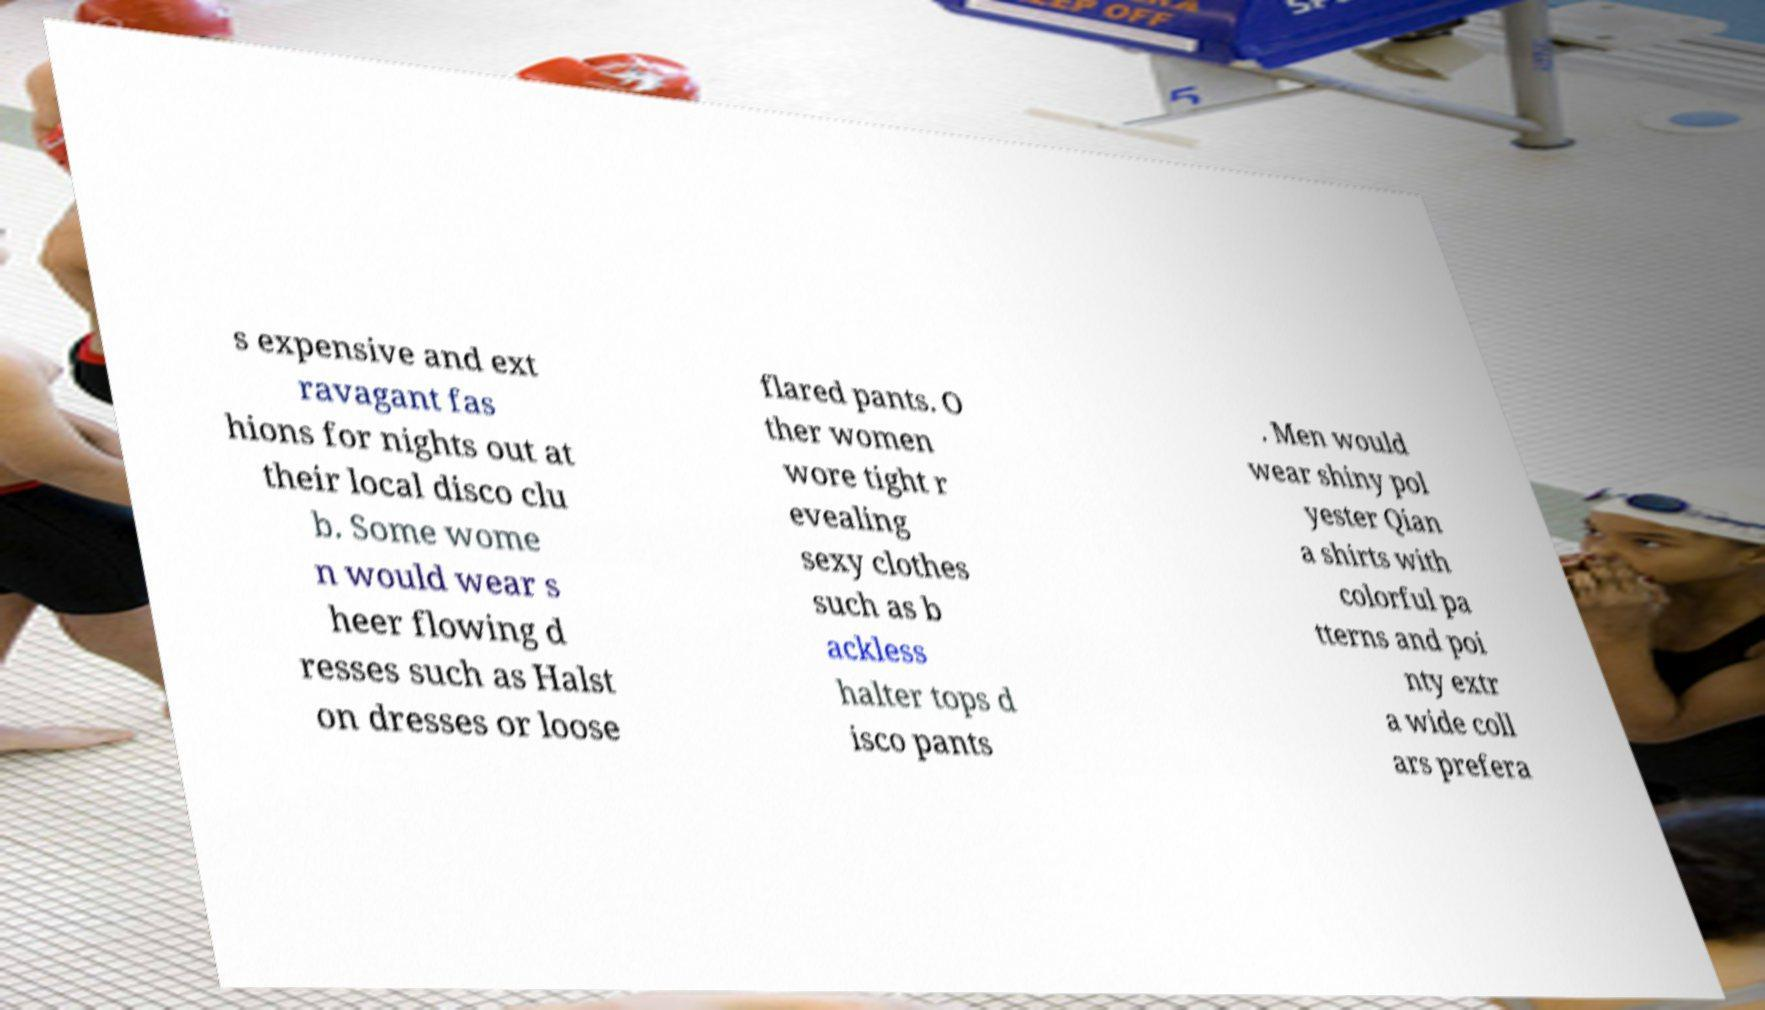There's text embedded in this image that I need extracted. Can you transcribe it verbatim? s expensive and ext ravagant fas hions for nights out at their local disco clu b. Some wome n would wear s heer flowing d resses such as Halst on dresses or loose flared pants. O ther women wore tight r evealing sexy clothes such as b ackless halter tops d isco pants . Men would wear shiny pol yester Qian a shirts with colorful pa tterns and poi nty extr a wide coll ars prefera 